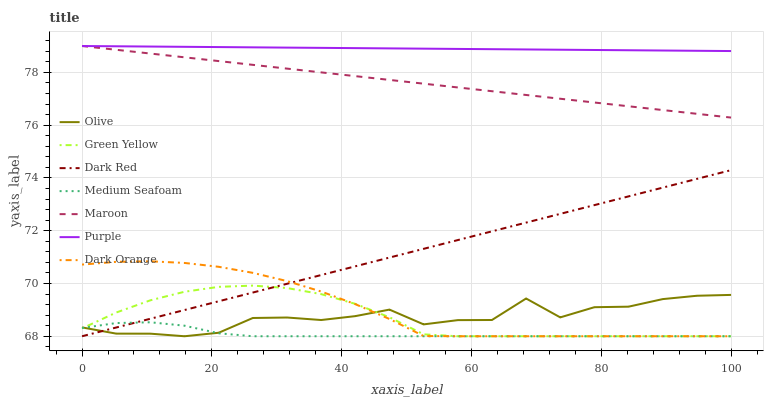Does Dark Red have the minimum area under the curve?
Answer yes or no. No. Does Dark Red have the maximum area under the curve?
Answer yes or no. No. Is Purple the smoothest?
Answer yes or no. No. Is Purple the roughest?
Answer yes or no. No. Does Purple have the lowest value?
Answer yes or no. No. Does Dark Red have the highest value?
Answer yes or no. No. Is Dark Red less than Purple?
Answer yes or no. Yes. Is Maroon greater than Dark Orange?
Answer yes or no. Yes. Does Dark Red intersect Purple?
Answer yes or no. No. 